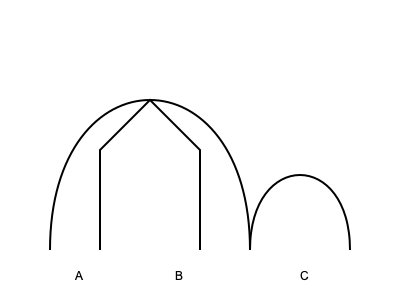Identify the classic film genres represented by the costume silhouettes A, B, and C in the image above. To answer this question, let's analyze each silhouette:

1. Silhouette A:
   - This shape features a wide, flowing bottom that resembles a ball gown.
   - The top is fitted, suggesting a corseted bodice.
   - This style is iconic of glamorous leading ladies in classic Hollywood romances and period dramas.

2. Silhouette B:
   - This shape has straight lines and sharp angles.
   - It resembles a person wearing a wide-brimmed hat and a long coat or trench coat.
   - This silhouette is characteristic of detectives or mysterious figures in film noir.

3. Silhouette C:
   - This shape shows a rounded, oversized top half.
   - The bottom half is relatively slim in comparison.
   - This exaggerated silhouette is typical of space suits or futuristic costumes in science fiction films.

Based on these analyses, we can identify the genres as follows:
A - Romance/Period Drama
B - Film Noir
C - Science Fiction
Answer: A: Romance/Period Drama, B: Film Noir, C: Science Fiction 